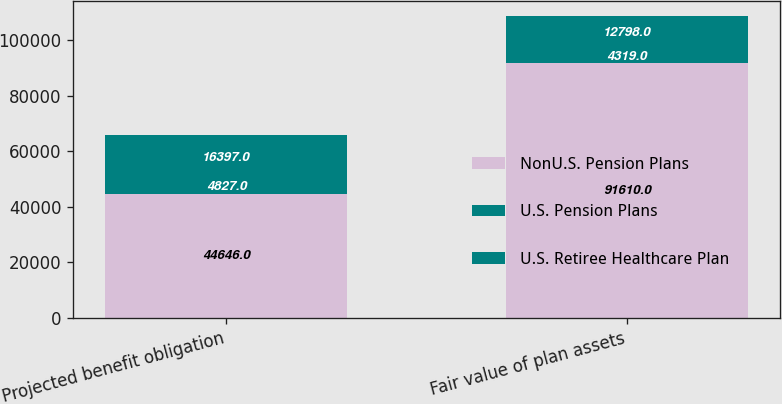Convert chart. <chart><loc_0><loc_0><loc_500><loc_500><stacked_bar_chart><ecel><fcel>Projected benefit obligation<fcel>Fair value of plan assets<nl><fcel>NonU.S. Pension Plans<fcel>44646<fcel>91610<nl><fcel>U.S. Pension Plans<fcel>4827<fcel>4319<nl><fcel>U.S. Retiree Healthcare Plan<fcel>16397<fcel>12798<nl></chart> 